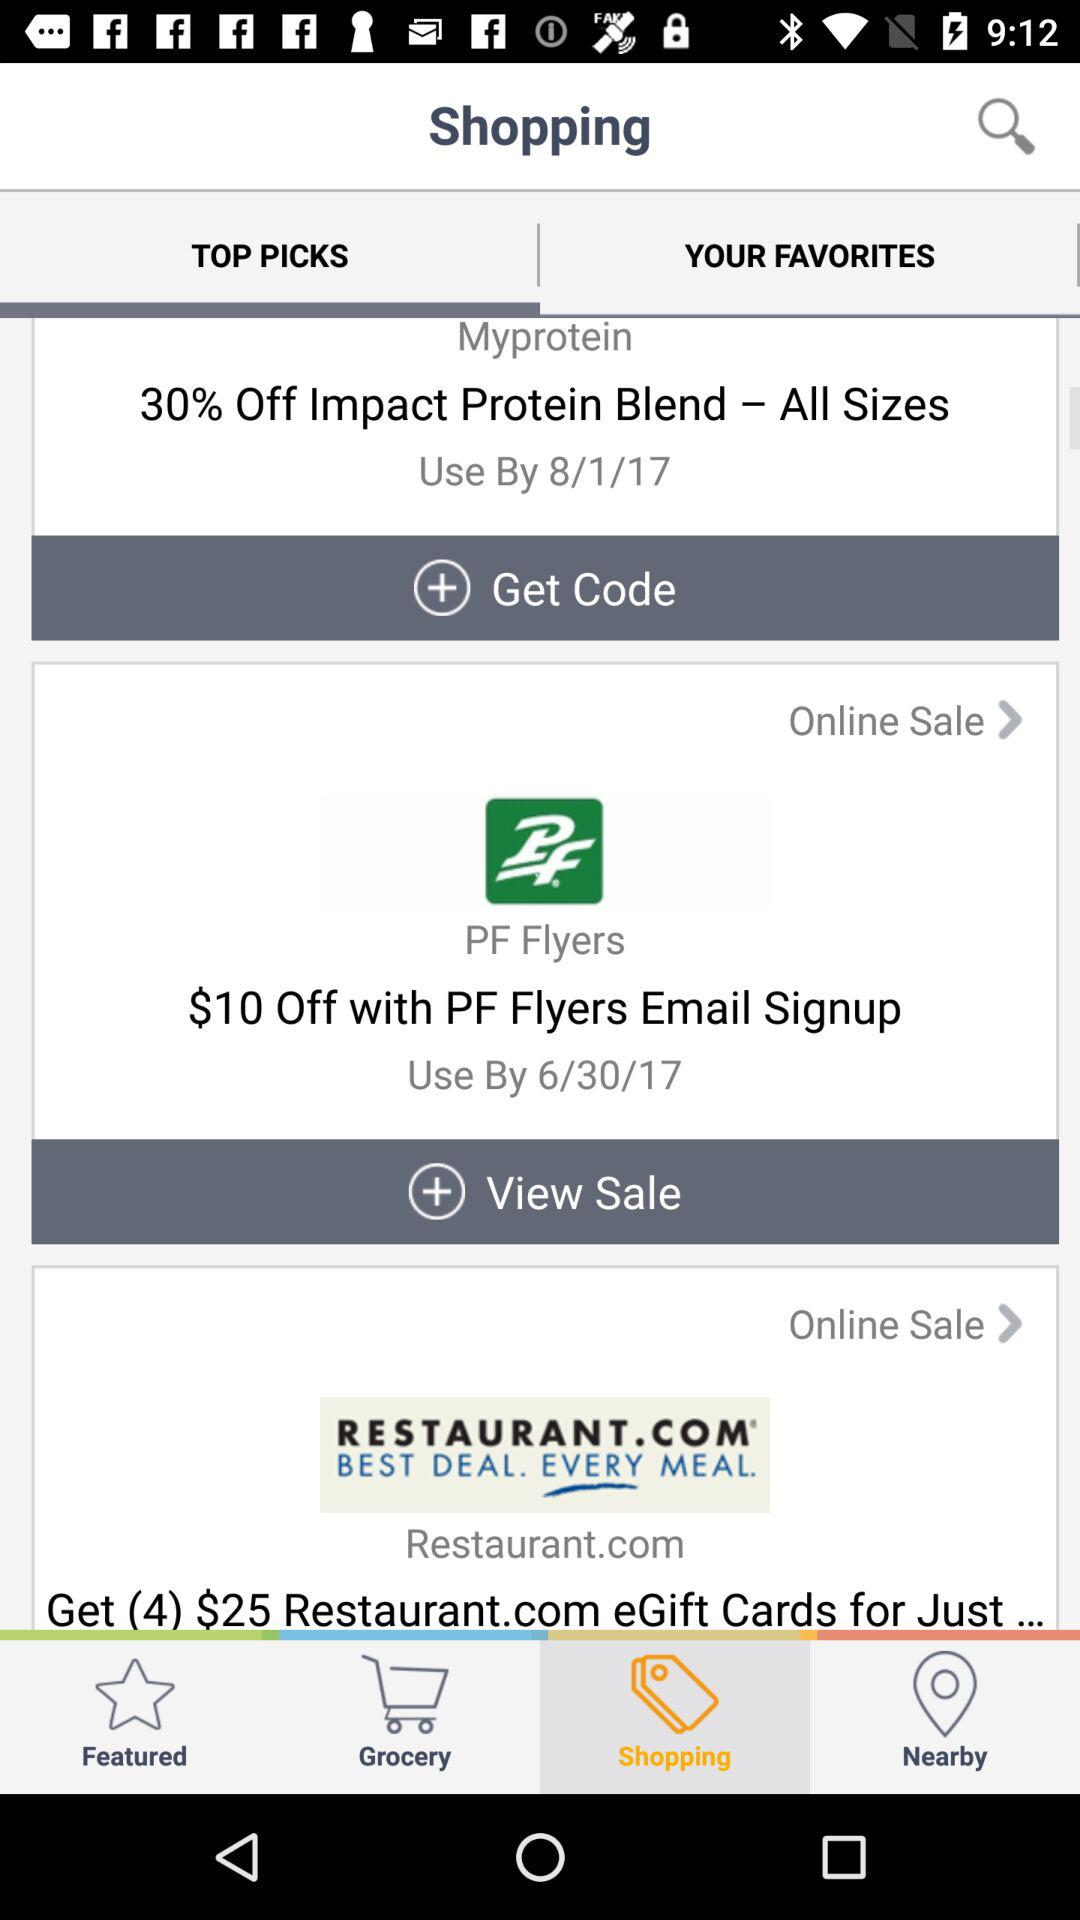What date is mentioned for "Myprotein"? The mentioned date is August 1, 2017. 